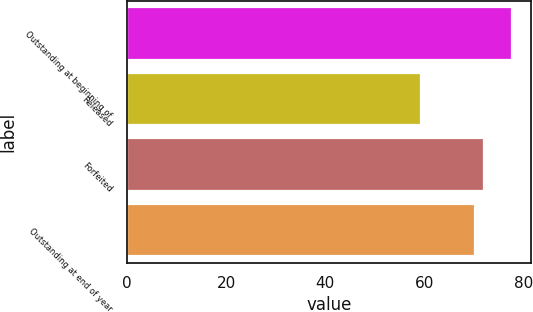Convert chart. <chart><loc_0><loc_0><loc_500><loc_500><bar_chart><fcel>Outstanding at beginning of<fcel>Released<fcel>Forfeited<fcel>Outstanding at end of year<nl><fcel>77.68<fcel>59.39<fcel>72.02<fcel>70.19<nl></chart> 